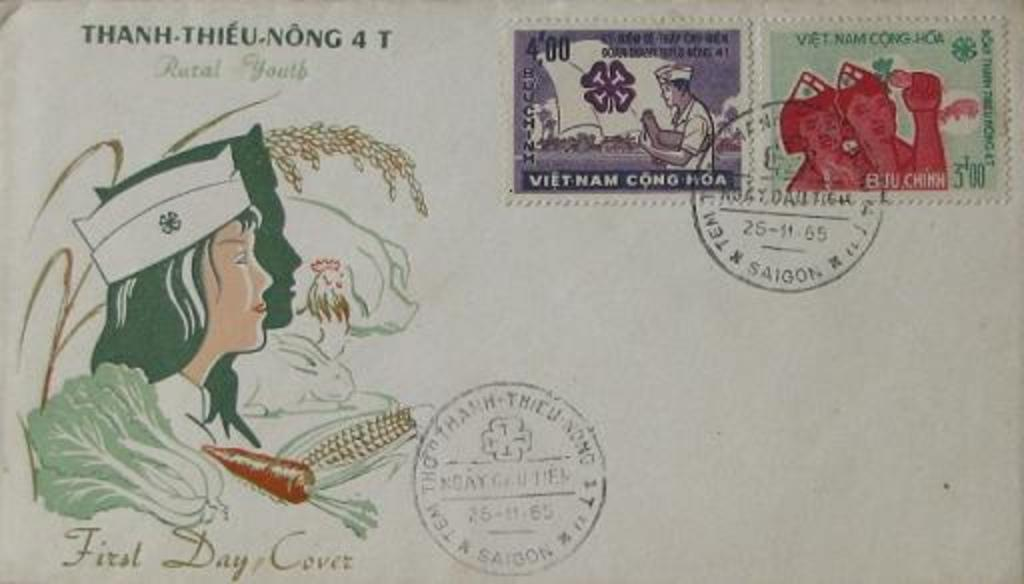<image>
Render a clear and concise summary of the photo. A postcard stamped from both Vietnam and China with an illustration of a nurse 